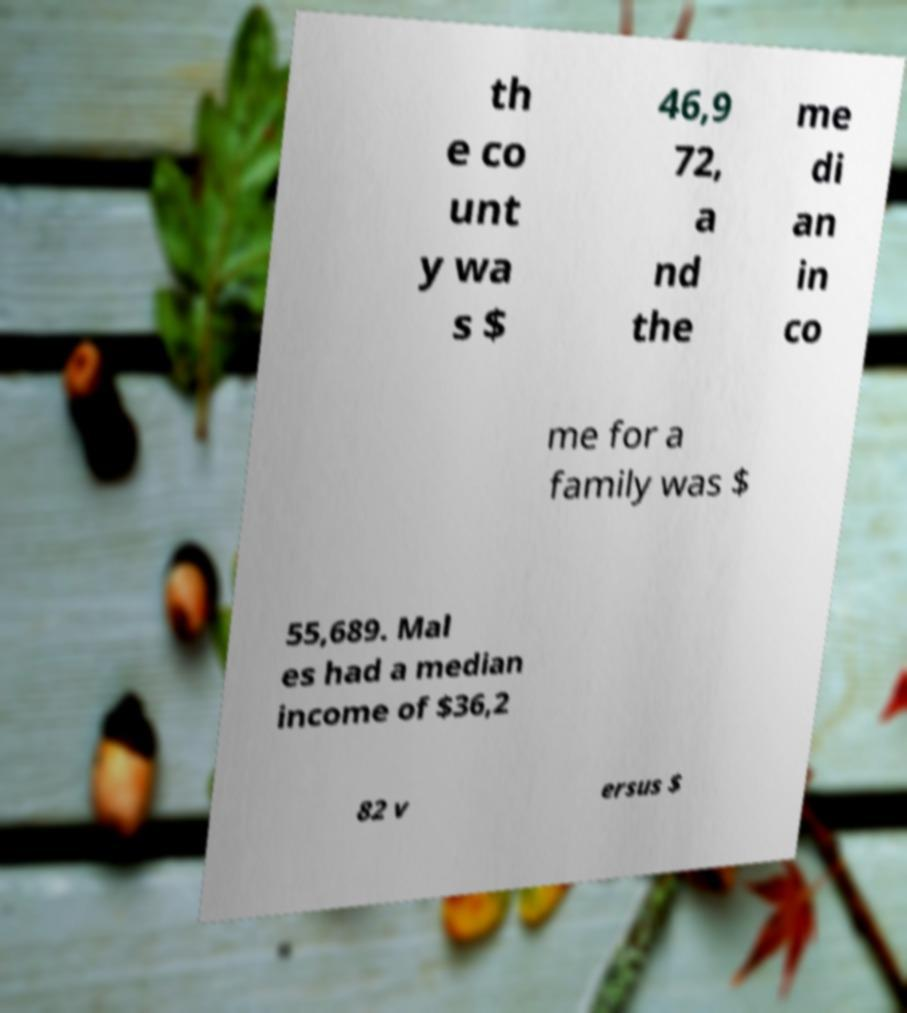Can you accurately transcribe the text from the provided image for me? th e co unt y wa s $ 46,9 72, a nd the me di an in co me for a family was $ 55,689. Mal es had a median income of $36,2 82 v ersus $ 